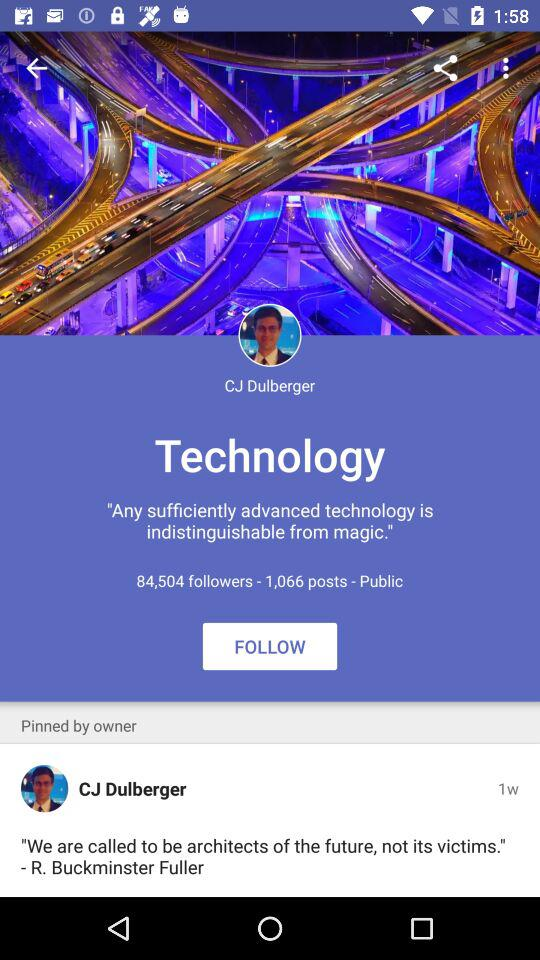How many followers are there on the profile? There are 84,504 followers. 